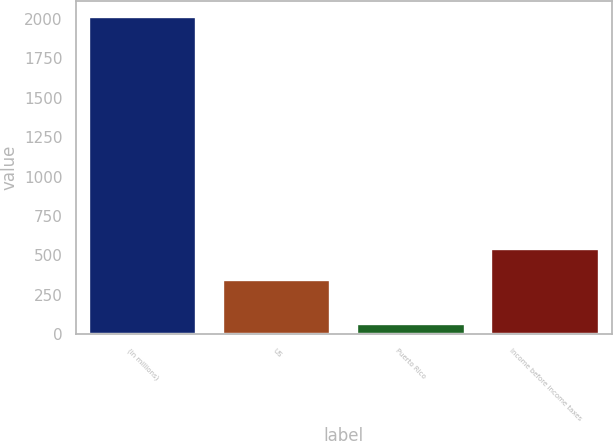<chart> <loc_0><loc_0><loc_500><loc_500><bar_chart><fcel>(in millions)<fcel>US<fcel>Puerto Rico<fcel>Income before income taxes<nl><fcel>2014<fcel>347<fcel>66<fcel>541.8<nl></chart> 